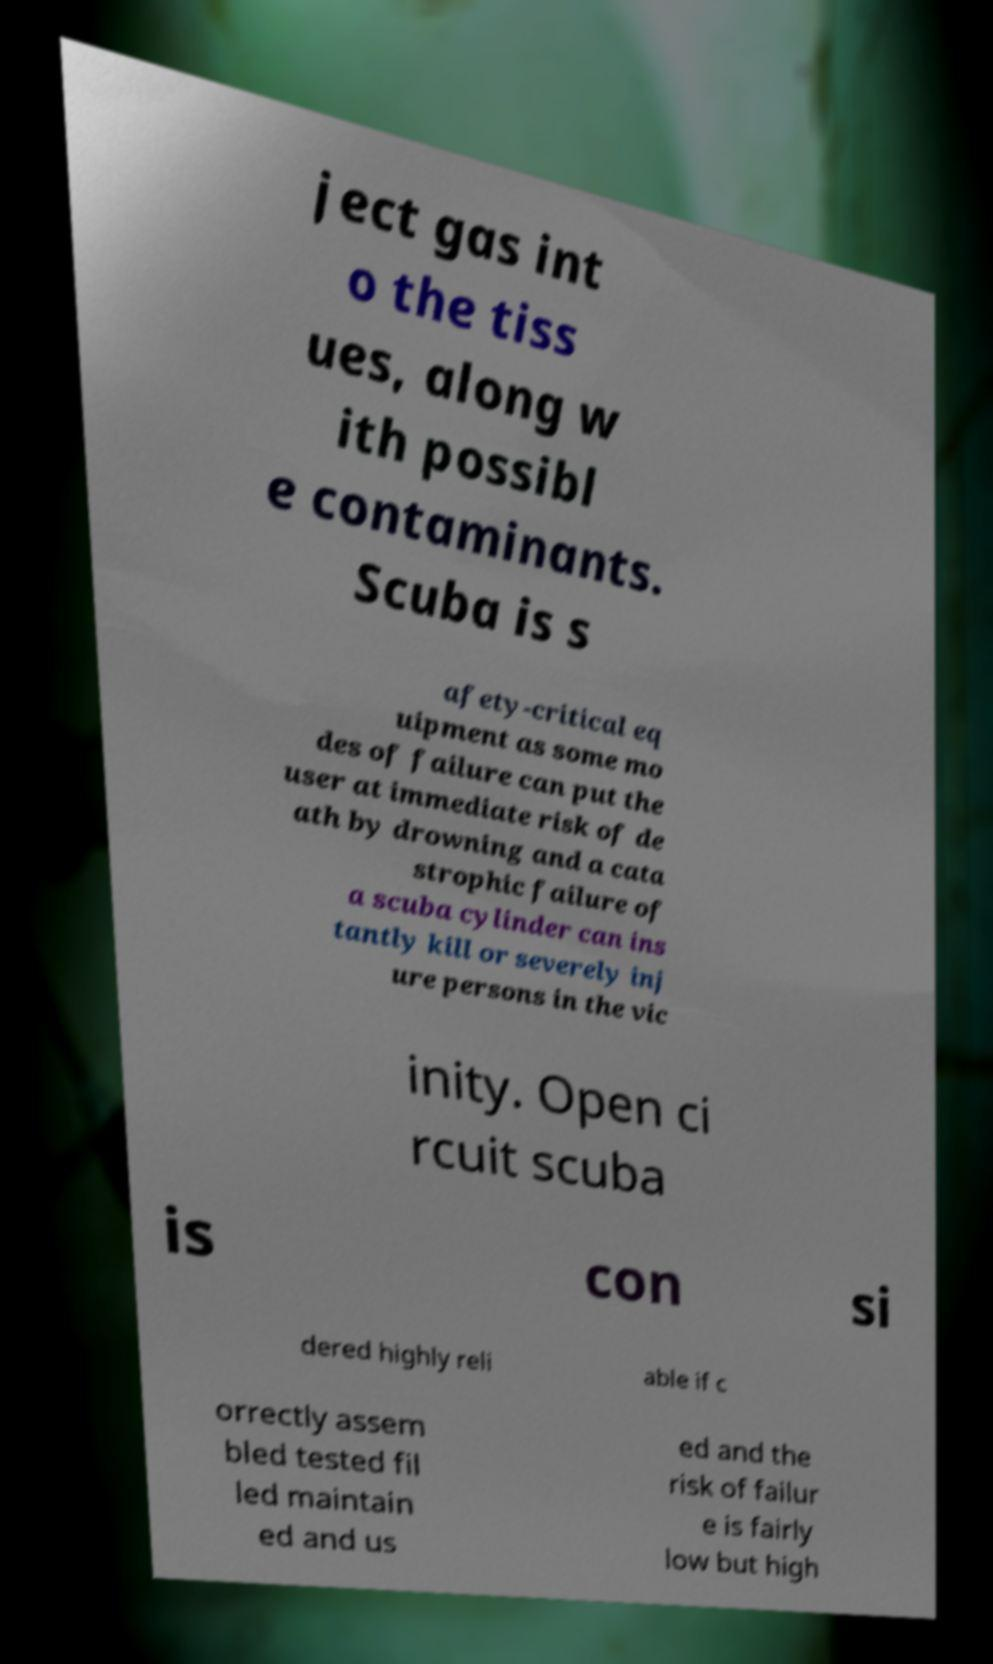Please read and relay the text visible in this image. What does it say? ject gas int o the tiss ues, along w ith possibl e contaminants. Scuba is s afety-critical eq uipment as some mo des of failure can put the user at immediate risk of de ath by drowning and a cata strophic failure of a scuba cylinder can ins tantly kill or severely inj ure persons in the vic inity. Open ci rcuit scuba is con si dered highly reli able if c orrectly assem bled tested fil led maintain ed and us ed and the risk of failur e is fairly low but high 